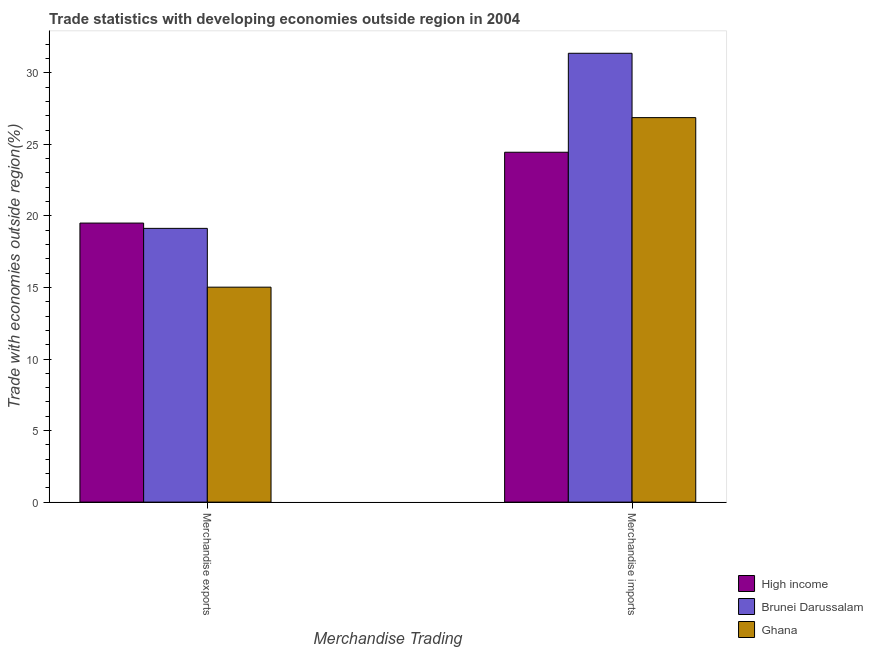How many groups of bars are there?
Provide a succinct answer. 2. Are the number of bars on each tick of the X-axis equal?
Offer a terse response. Yes. How many bars are there on the 1st tick from the left?
Provide a short and direct response. 3. How many bars are there on the 1st tick from the right?
Provide a succinct answer. 3. What is the merchandise exports in Ghana?
Ensure brevity in your answer.  15.02. Across all countries, what is the maximum merchandise exports?
Your response must be concise. 19.5. Across all countries, what is the minimum merchandise exports?
Your response must be concise. 15.02. In which country was the merchandise exports maximum?
Ensure brevity in your answer.  High income. In which country was the merchandise exports minimum?
Provide a short and direct response. Ghana. What is the total merchandise imports in the graph?
Offer a very short reply. 82.67. What is the difference between the merchandise imports in High income and that in Ghana?
Make the answer very short. -2.42. What is the difference between the merchandise imports in High income and the merchandise exports in Brunei Darussalam?
Provide a succinct answer. 5.32. What is the average merchandise imports per country?
Provide a succinct answer. 27.56. What is the difference between the merchandise imports and merchandise exports in Ghana?
Your answer should be very brief. 11.85. In how many countries, is the merchandise imports greater than 24 %?
Your response must be concise. 3. What is the ratio of the merchandise imports in High income to that in Brunei Darussalam?
Your response must be concise. 0.78. What does the 3rd bar from the left in Merchandise imports represents?
Offer a terse response. Ghana. What does the 1st bar from the right in Merchandise imports represents?
Your answer should be compact. Ghana. How many bars are there?
Give a very brief answer. 6. What is the difference between two consecutive major ticks on the Y-axis?
Provide a short and direct response. 5. Are the values on the major ticks of Y-axis written in scientific E-notation?
Provide a short and direct response. No. Does the graph contain any zero values?
Offer a terse response. No. Does the graph contain grids?
Provide a short and direct response. No. How many legend labels are there?
Your response must be concise. 3. How are the legend labels stacked?
Your answer should be very brief. Vertical. What is the title of the graph?
Your answer should be very brief. Trade statistics with developing economies outside region in 2004. What is the label or title of the X-axis?
Your answer should be very brief. Merchandise Trading. What is the label or title of the Y-axis?
Your response must be concise. Trade with economies outside region(%). What is the Trade with economies outside region(%) in High income in Merchandise exports?
Provide a short and direct response. 19.5. What is the Trade with economies outside region(%) in Brunei Darussalam in Merchandise exports?
Give a very brief answer. 19.13. What is the Trade with economies outside region(%) in Ghana in Merchandise exports?
Offer a very short reply. 15.02. What is the Trade with economies outside region(%) of High income in Merchandise imports?
Give a very brief answer. 24.45. What is the Trade with economies outside region(%) of Brunei Darussalam in Merchandise imports?
Keep it short and to the point. 31.36. What is the Trade with economies outside region(%) of Ghana in Merchandise imports?
Give a very brief answer. 26.87. Across all Merchandise Trading, what is the maximum Trade with economies outside region(%) of High income?
Ensure brevity in your answer.  24.45. Across all Merchandise Trading, what is the maximum Trade with economies outside region(%) of Brunei Darussalam?
Your answer should be compact. 31.36. Across all Merchandise Trading, what is the maximum Trade with economies outside region(%) of Ghana?
Provide a succinct answer. 26.87. Across all Merchandise Trading, what is the minimum Trade with economies outside region(%) of High income?
Ensure brevity in your answer.  19.5. Across all Merchandise Trading, what is the minimum Trade with economies outside region(%) in Brunei Darussalam?
Your answer should be compact. 19.13. Across all Merchandise Trading, what is the minimum Trade with economies outside region(%) in Ghana?
Your answer should be compact. 15.02. What is the total Trade with economies outside region(%) of High income in the graph?
Offer a very short reply. 43.94. What is the total Trade with economies outside region(%) of Brunei Darussalam in the graph?
Offer a terse response. 50.49. What is the total Trade with economies outside region(%) of Ghana in the graph?
Keep it short and to the point. 41.89. What is the difference between the Trade with economies outside region(%) in High income in Merchandise exports and that in Merchandise imports?
Offer a very short reply. -4.95. What is the difference between the Trade with economies outside region(%) of Brunei Darussalam in Merchandise exports and that in Merchandise imports?
Give a very brief answer. -12.23. What is the difference between the Trade with economies outside region(%) in Ghana in Merchandise exports and that in Merchandise imports?
Offer a terse response. -11.85. What is the difference between the Trade with economies outside region(%) in High income in Merchandise exports and the Trade with economies outside region(%) in Brunei Darussalam in Merchandise imports?
Make the answer very short. -11.86. What is the difference between the Trade with economies outside region(%) in High income in Merchandise exports and the Trade with economies outside region(%) in Ghana in Merchandise imports?
Provide a succinct answer. -7.37. What is the difference between the Trade with economies outside region(%) of Brunei Darussalam in Merchandise exports and the Trade with economies outside region(%) of Ghana in Merchandise imports?
Keep it short and to the point. -7.74. What is the average Trade with economies outside region(%) of High income per Merchandise Trading?
Your response must be concise. 21.97. What is the average Trade with economies outside region(%) in Brunei Darussalam per Merchandise Trading?
Give a very brief answer. 25.24. What is the average Trade with economies outside region(%) of Ghana per Merchandise Trading?
Provide a succinct answer. 20.94. What is the difference between the Trade with economies outside region(%) of High income and Trade with economies outside region(%) of Brunei Darussalam in Merchandise exports?
Offer a terse response. 0.37. What is the difference between the Trade with economies outside region(%) in High income and Trade with economies outside region(%) in Ghana in Merchandise exports?
Give a very brief answer. 4.48. What is the difference between the Trade with economies outside region(%) of Brunei Darussalam and Trade with economies outside region(%) of Ghana in Merchandise exports?
Offer a terse response. 4.11. What is the difference between the Trade with economies outside region(%) in High income and Trade with economies outside region(%) in Brunei Darussalam in Merchandise imports?
Provide a succinct answer. -6.92. What is the difference between the Trade with economies outside region(%) in High income and Trade with economies outside region(%) in Ghana in Merchandise imports?
Provide a succinct answer. -2.42. What is the difference between the Trade with economies outside region(%) of Brunei Darussalam and Trade with economies outside region(%) of Ghana in Merchandise imports?
Offer a terse response. 4.5. What is the ratio of the Trade with economies outside region(%) in High income in Merchandise exports to that in Merchandise imports?
Your answer should be compact. 0.8. What is the ratio of the Trade with economies outside region(%) of Brunei Darussalam in Merchandise exports to that in Merchandise imports?
Your answer should be compact. 0.61. What is the ratio of the Trade with economies outside region(%) in Ghana in Merchandise exports to that in Merchandise imports?
Your answer should be compact. 0.56. What is the difference between the highest and the second highest Trade with economies outside region(%) of High income?
Make the answer very short. 4.95. What is the difference between the highest and the second highest Trade with economies outside region(%) of Brunei Darussalam?
Offer a terse response. 12.23. What is the difference between the highest and the second highest Trade with economies outside region(%) of Ghana?
Your answer should be compact. 11.85. What is the difference between the highest and the lowest Trade with economies outside region(%) of High income?
Offer a terse response. 4.95. What is the difference between the highest and the lowest Trade with economies outside region(%) of Brunei Darussalam?
Make the answer very short. 12.23. What is the difference between the highest and the lowest Trade with economies outside region(%) in Ghana?
Ensure brevity in your answer.  11.85. 